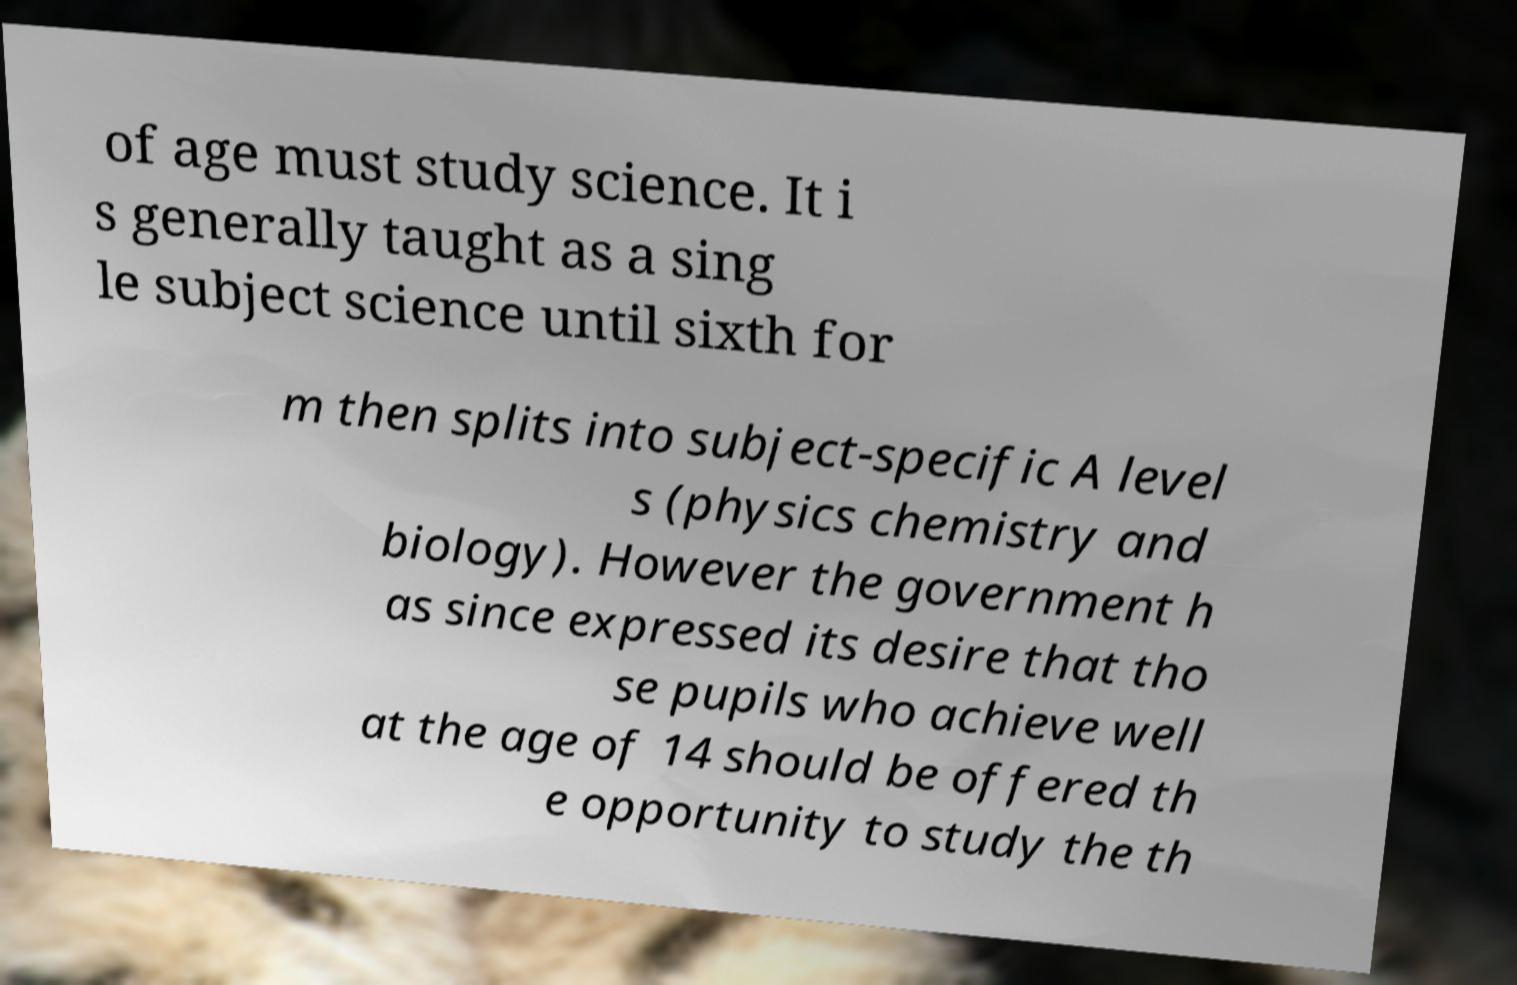Can you read and provide the text displayed in the image?This photo seems to have some interesting text. Can you extract and type it out for me? of age must study science. It i s generally taught as a sing le subject science until sixth for m then splits into subject-specific A level s (physics chemistry and biology). However the government h as since expressed its desire that tho se pupils who achieve well at the age of 14 should be offered th e opportunity to study the th 